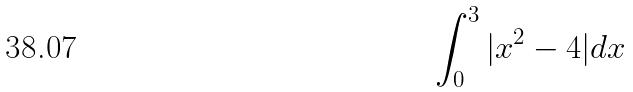<formula> <loc_0><loc_0><loc_500><loc_500>\int _ { 0 } ^ { 3 } | x ^ { 2 } - 4 | d x</formula> 